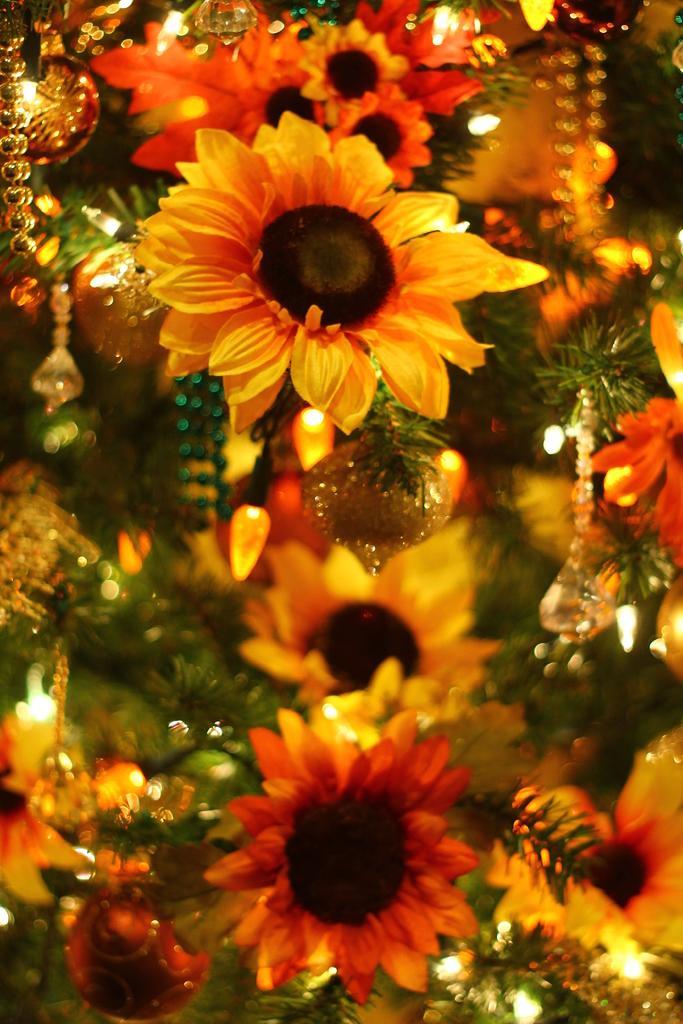Please provide a concise description of this image. In this picture I can see the sunflowers, for decoration and the lights. 